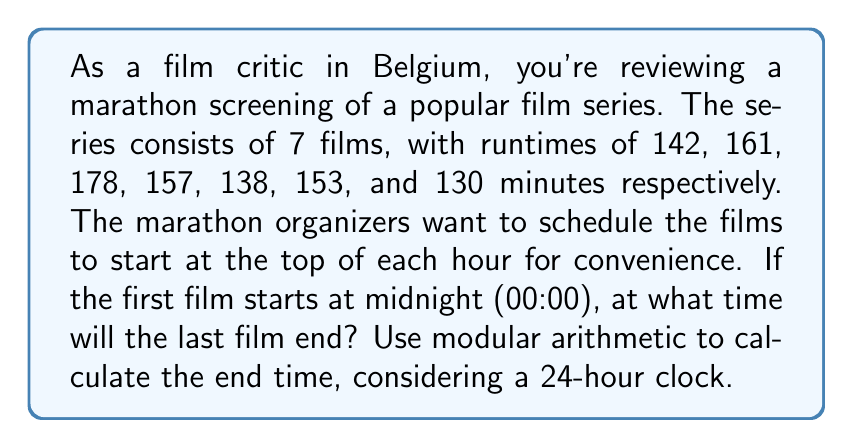Can you solve this math problem? Let's approach this step-by-step:

1) First, calculate the total runtime of all 7 films:
   $$142 + 161 + 178 + 157 + 138 + 153 + 130 = 1059$$ minutes

2) Convert 1059 minutes to hours and minutes:
   $$1059 \div 60 = 17$$ hours with a remainder of 39 minutes
   So, the total runtime is 17 hours and 39 minutes

3) Since the films start at the top of each hour, we need to round up to the nearest hour for each film. This means adding an extra hour for every film except the last one:
   $$17 + 6 = 23$$ hours

4) Now we have 23 hours and 39 minutes

5) Using modular arithmetic with a 24-hour clock:
   $$(23 + 0) \bmod 24 = 23$$
   So, it will end at 23:39

6) Converting 23:39 to standard time:
   23:39 is equivalent to 11:39 PM

Therefore, if the marathon starts at midnight (00:00), the last film will end at 11:39 PM the next day.
Answer: 23:39 or 11:39 PM 